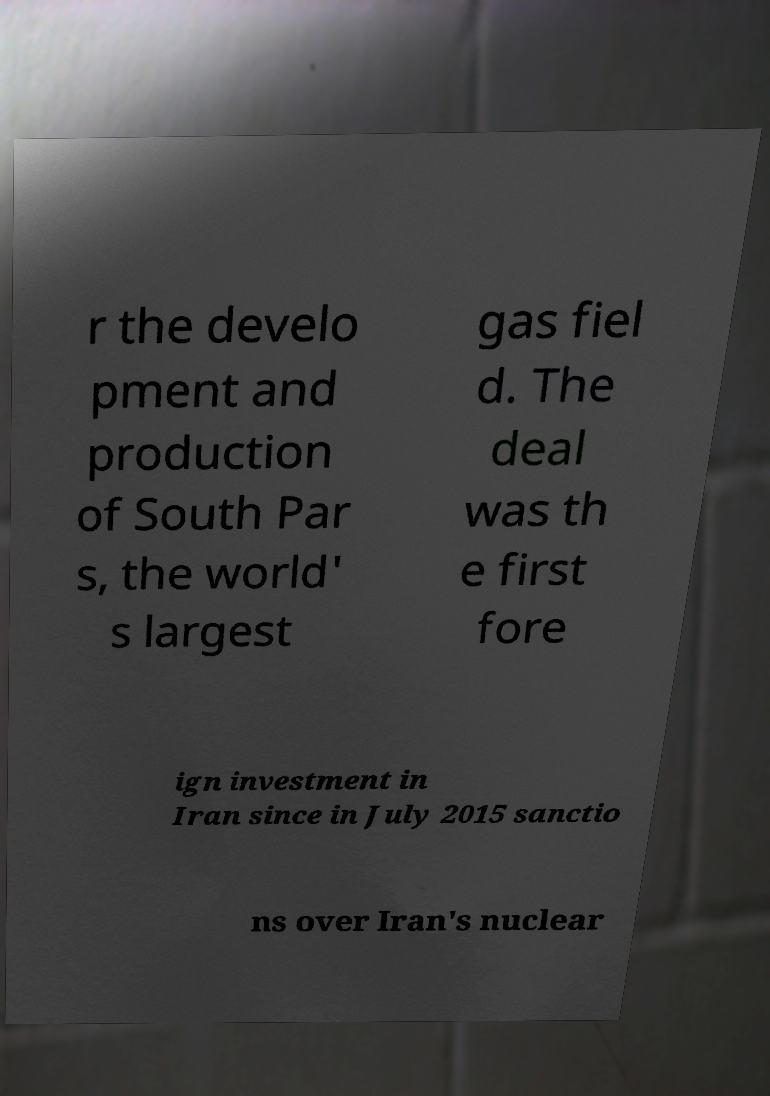What messages or text are displayed in this image? I need them in a readable, typed format. r the develo pment and production of South Par s, the world' s largest gas fiel d. The deal was th e first fore ign investment in Iran since in July 2015 sanctio ns over Iran's nuclear 